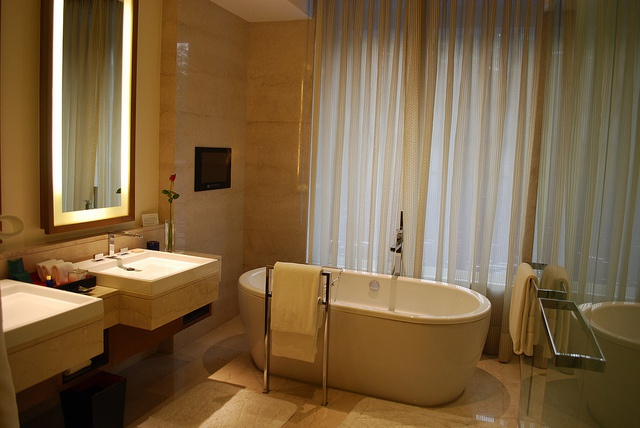Describe the objects in this image and their specific colors. I can see sink in black, olive, beige, and tan tones, sink in black, tan, beige, and maroon tones, tv in black, maroon, and olive tones, and vase in black, olive, gray, and tan tones in this image. 